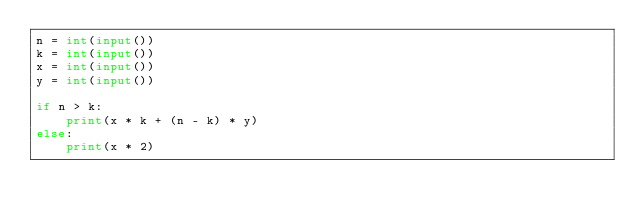<code> <loc_0><loc_0><loc_500><loc_500><_Python_>n = int(input())
k = int(input())
x = int(input())
y = int(input())

if n > k:
    print(x * k + (n - k) * y)
else:
    print(x * 2)</code> 